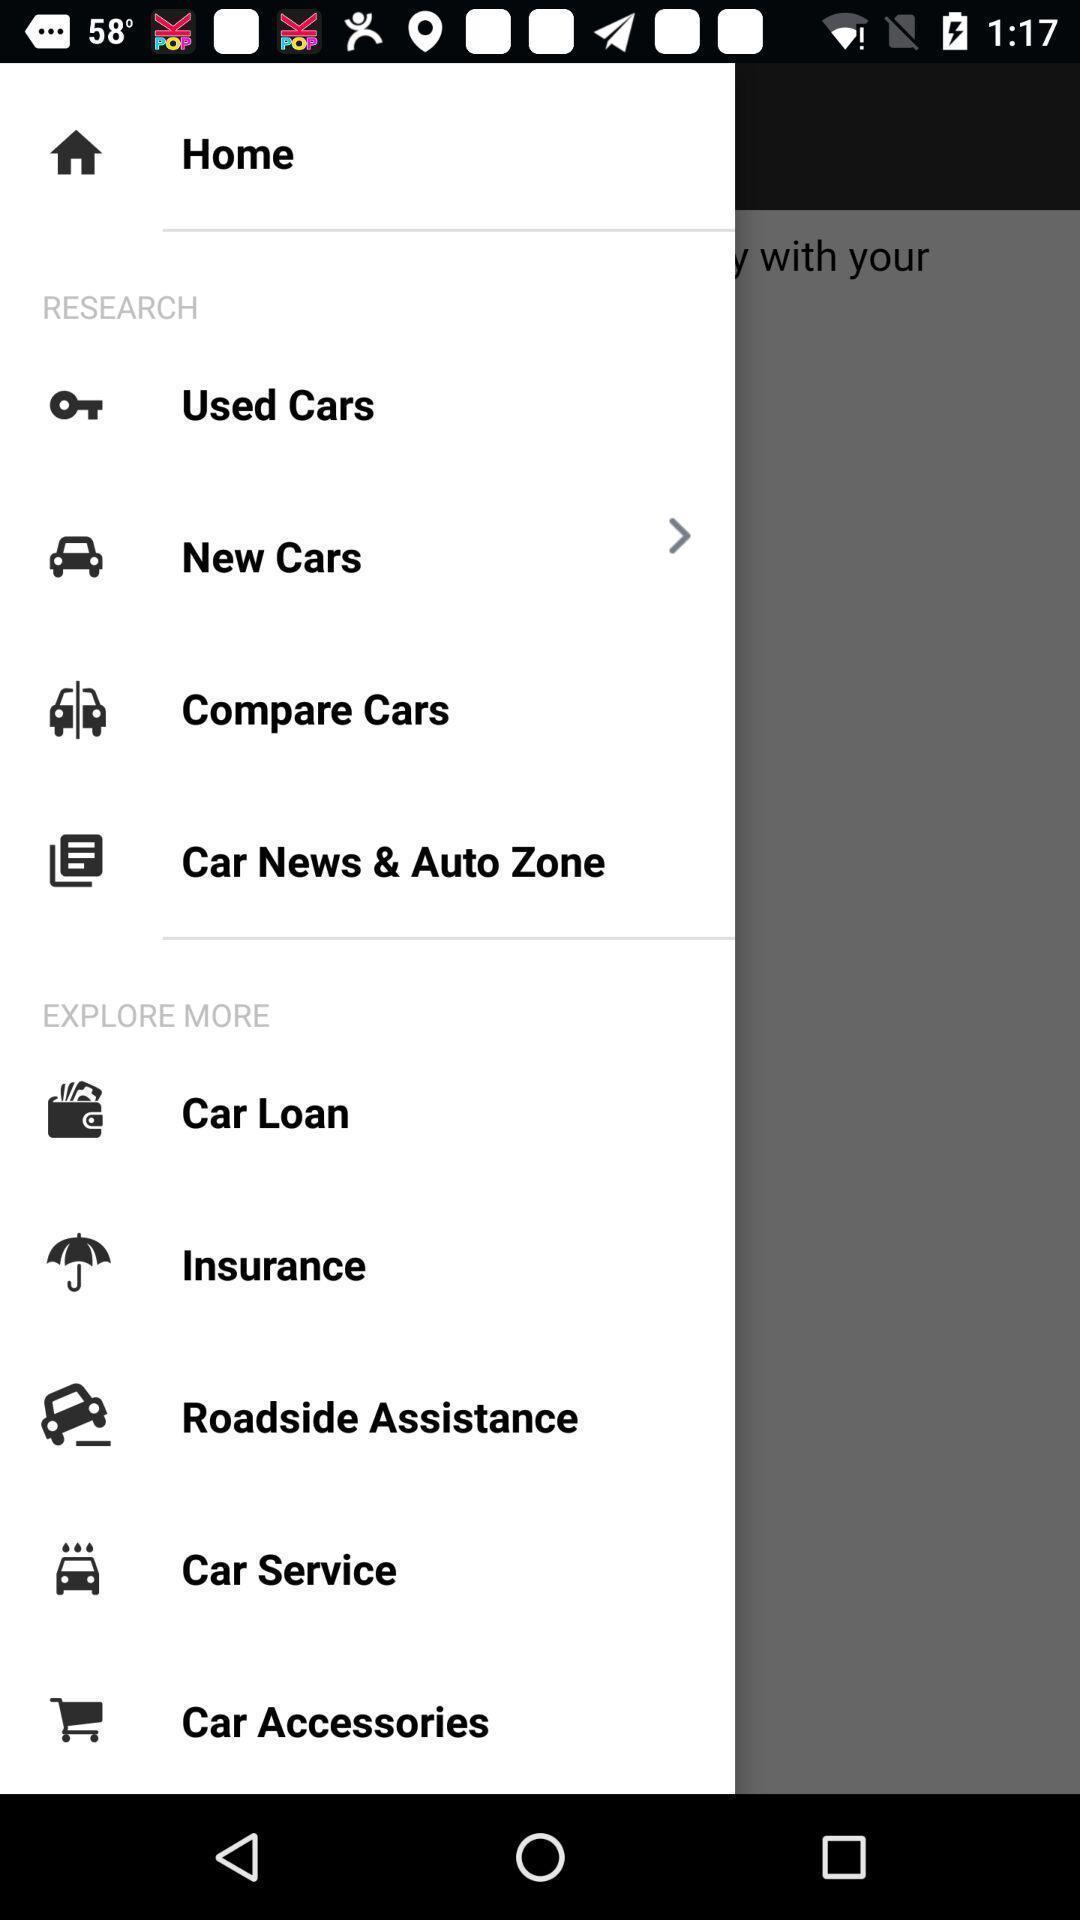Give me a summary of this screen capture. Page showing list of various options of a services app. 